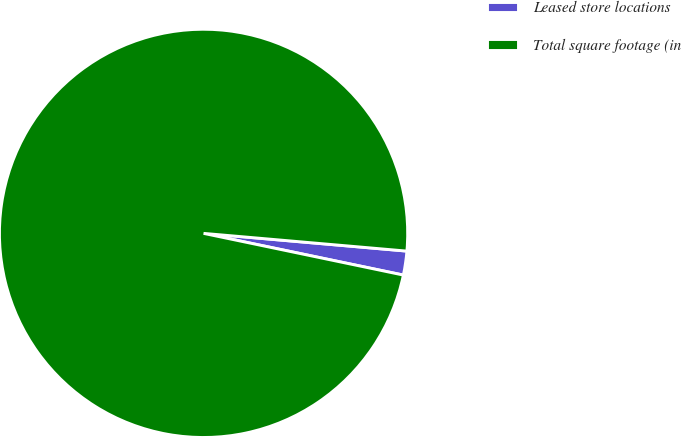<chart> <loc_0><loc_0><loc_500><loc_500><pie_chart><fcel>Leased store locations<fcel>Total square footage (in<nl><fcel>1.89%<fcel>98.11%<nl></chart> 